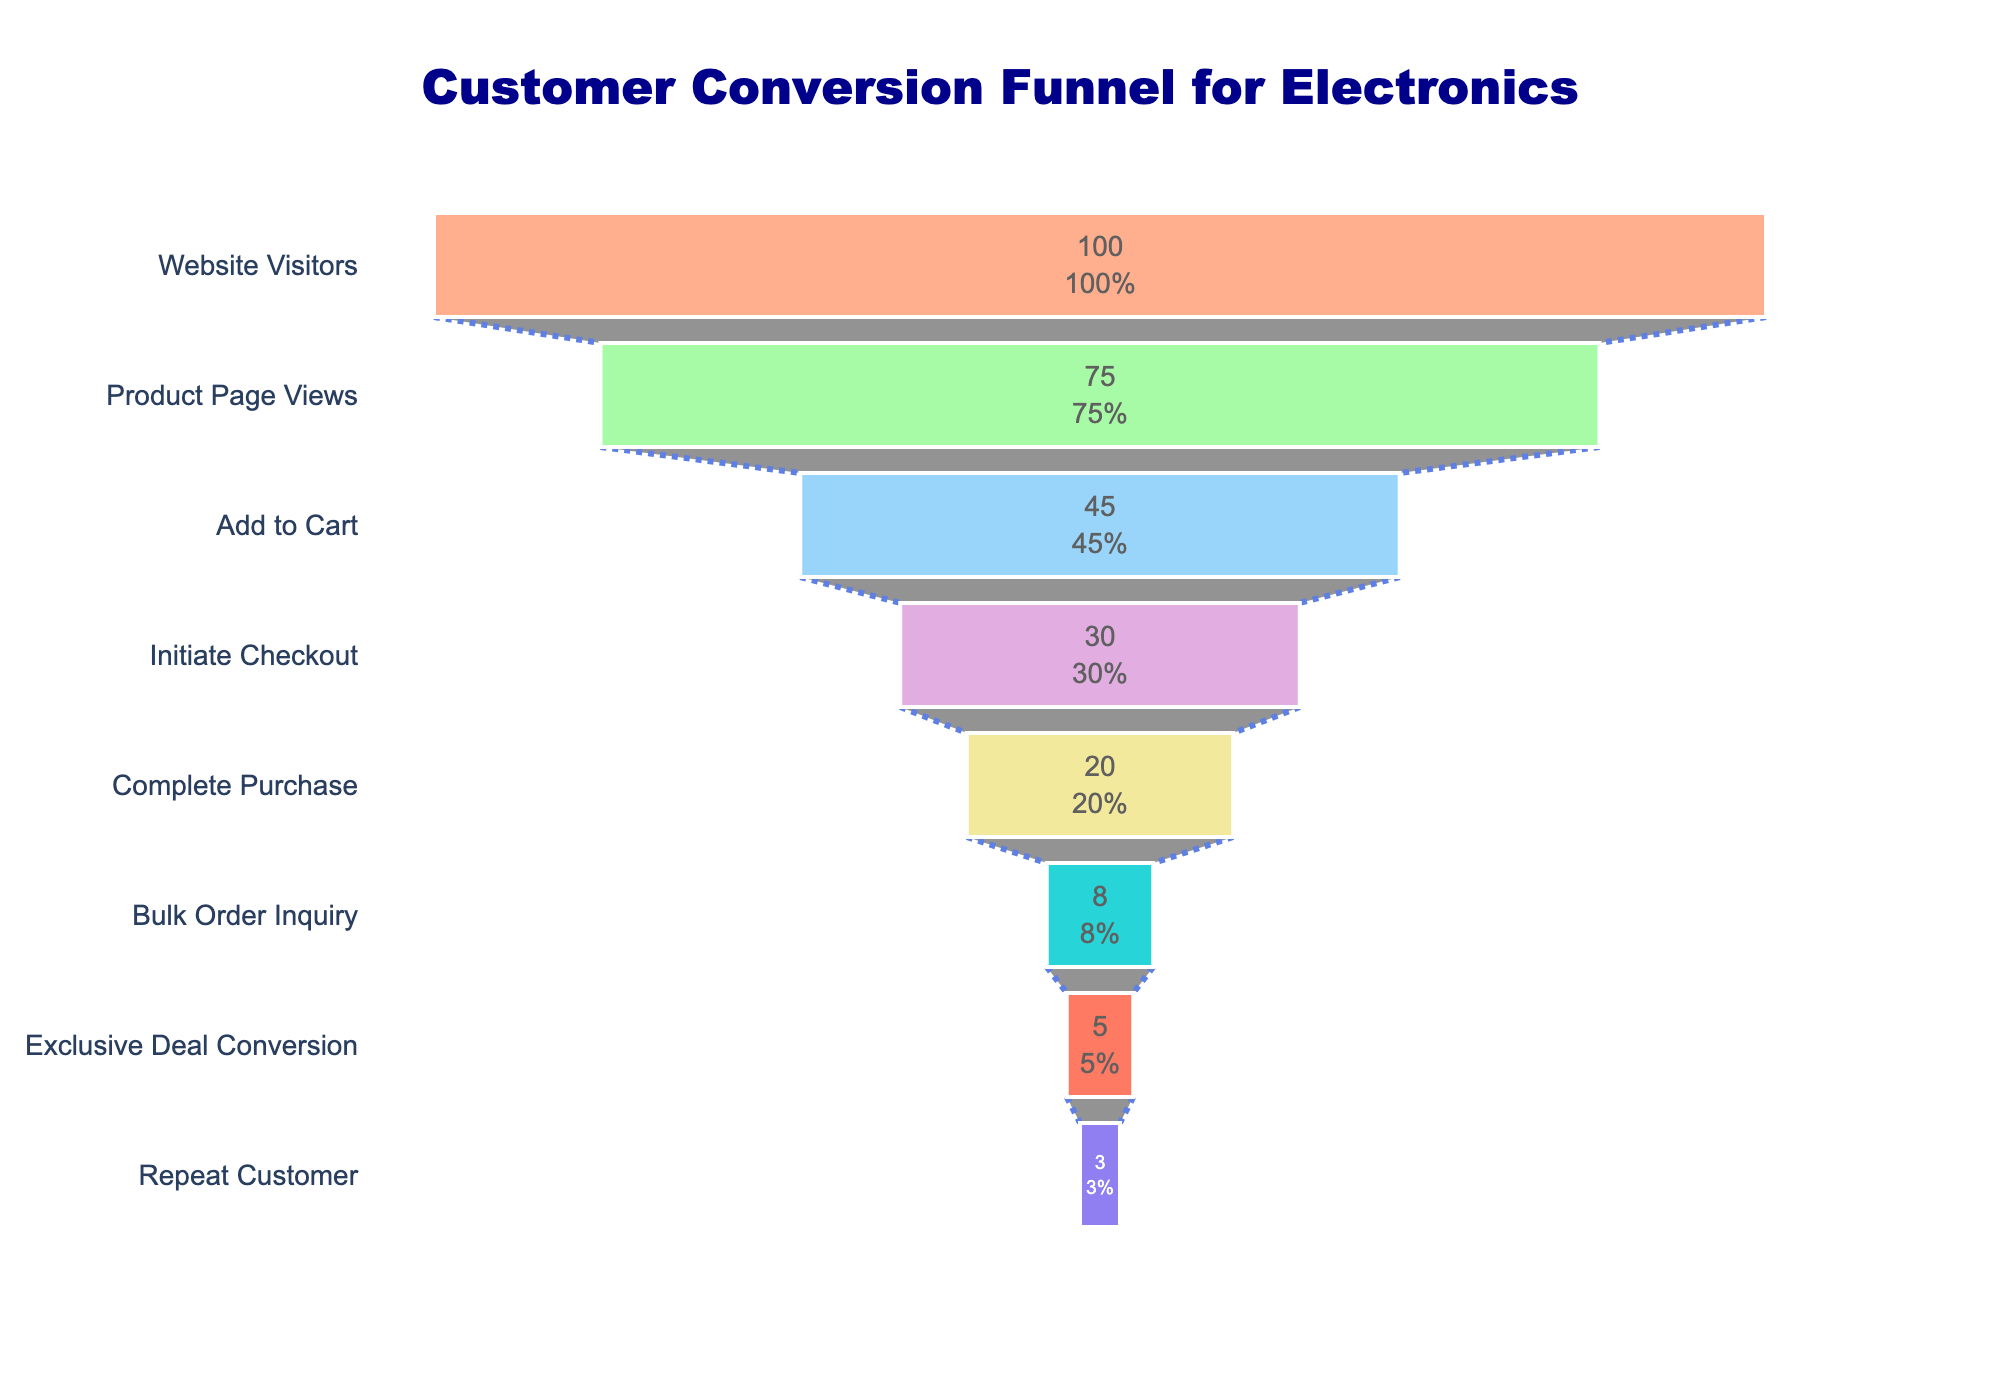What is the title of the funnel chart? The title is the text positioned at the top of the funnel chart, usually in a larger font size and in a distinguishable color for easy recognition.
Answer: Customer Conversion Funnel for Electronics How many stages are shown in this funnel chart? The stages in a funnel chart are usually labeled on the right side of the chart. By counting these labels, we can determine the total number of stages.
Answer: 8 What is the conversion rate from "Website Visitors" to "Complete Purchase"? The conversion rate from "Website Visitors" is initially 100%. The rate for "Complete Purchase" is 20%. By observing the values next to these labels, we find the conversion rate.
Answer: 20% Which stage experiences the largest drop in conversion rate? By examining the conversion rates from each stage to the next, the largest drop can be identified where there's the most significant percentage decrease. From "Initiate Checkout" (30%) to "Complete Purchase" (20%) is a 10% drop.
Answer: Complete Purchase What's the difference in conversion rate between "Add to Cart" and "Exclusive Deal Conversion"? Look at the conversion rate values for both "Add to Cart" (45%) and "Exclusive Deal Conversion" (5%), then perform a subtraction: 45% - 5% = 40%.
Answer: 40% Which stage has a lower conversion rate, "Bulk Order Inquiry" or "Repeat Customer"? Compare the conversion rates for "Bulk Order Inquiry" (8%) and "Repeat Customer" (3%). The one with the lower percentage is the answer.
Answer: Repeat Customer What color represents the "Initiate Checkout" stage in the funnel? The funnel chart uses different colors for each stage, identified by the color of the respective stage label. The color for "Initiate Checkout" is observed to be purple.
Answer: Purple How does the conversion rate for "Product Page Views" compare to "Add to Cart"? By comparing the conversion rates, 75% for "Product Page Views" and 45% for "Add to Cart", it can be seen that "Product Page Views" is higher.
Answer: Product Page Views is higher If a customer reaches "Initiate Checkout," what is the likelihood they will complete a purchase? Starting at "Initiate Checkout" (30%), the conversion to "Complete Purchase" (20%) happens, calculated as a new rate by considering the relative change (20/30).
Answer: 66.7% What steps have the closest conversion rates? By comparing each step's conversion rates, find the two stages with the smallest difference in percentage. "Website Visitors" (100%) to "Product Page Views" (75%) have a 25% drop, which is closest compared to other differences.
Answer: Website Visitors to Product Page Views 